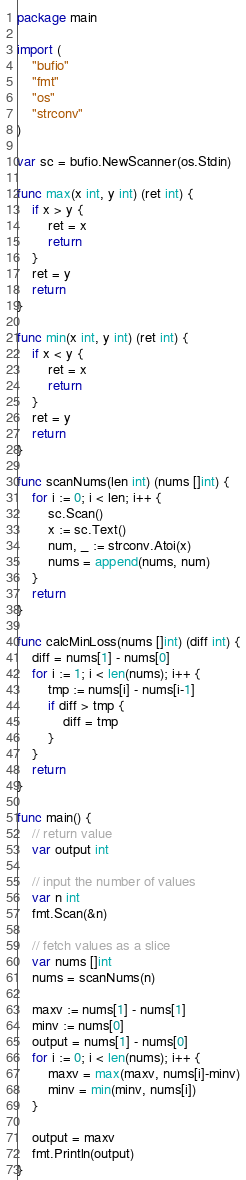<code> <loc_0><loc_0><loc_500><loc_500><_Go_>package main

import (
	"bufio"
	"fmt"
	"os"
	"strconv"
)

var sc = bufio.NewScanner(os.Stdin)

func max(x int, y int) (ret int) {
	if x > y {
		ret = x
		return
	}
	ret = y
	return
}

func min(x int, y int) (ret int) {
	if x < y {
		ret = x
		return
	}
	ret = y
	return
}

func scanNums(len int) (nums []int) {
	for i := 0; i < len; i++ {
		sc.Scan()
		x := sc.Text()
		num, _ := strconv.Atoi(x)
		nums = append(nums, num)
	}
	return
}

func calcMinLoss(nums []int) (diff int) {
	diff = nums[1] - nums[0]
	for i := 1; i < len(nums); i++ {
		tmp := nums[i] - nums[i-1]
		if diff > tmp {
			diff = tmp
		}
	}
	return
}

func main() {
	// return value
	var output int

	// input the number of values
	var n int
	fmt.Scan(&n)

	// fetch values as a slice
	var nums []int
	nums = scanNums(n)

	maxv := nums[1] - nums[1]
	minv := nums[0]
	output = nums[1] - nums[0]
	for i := 0; i < len(nums); i++ {
		maxv = max(maxv, nums[i]-minv)
		minv = min(minv, nums[i])
	}

	output = maxv
	fmt.Println(output)
}

</code> 